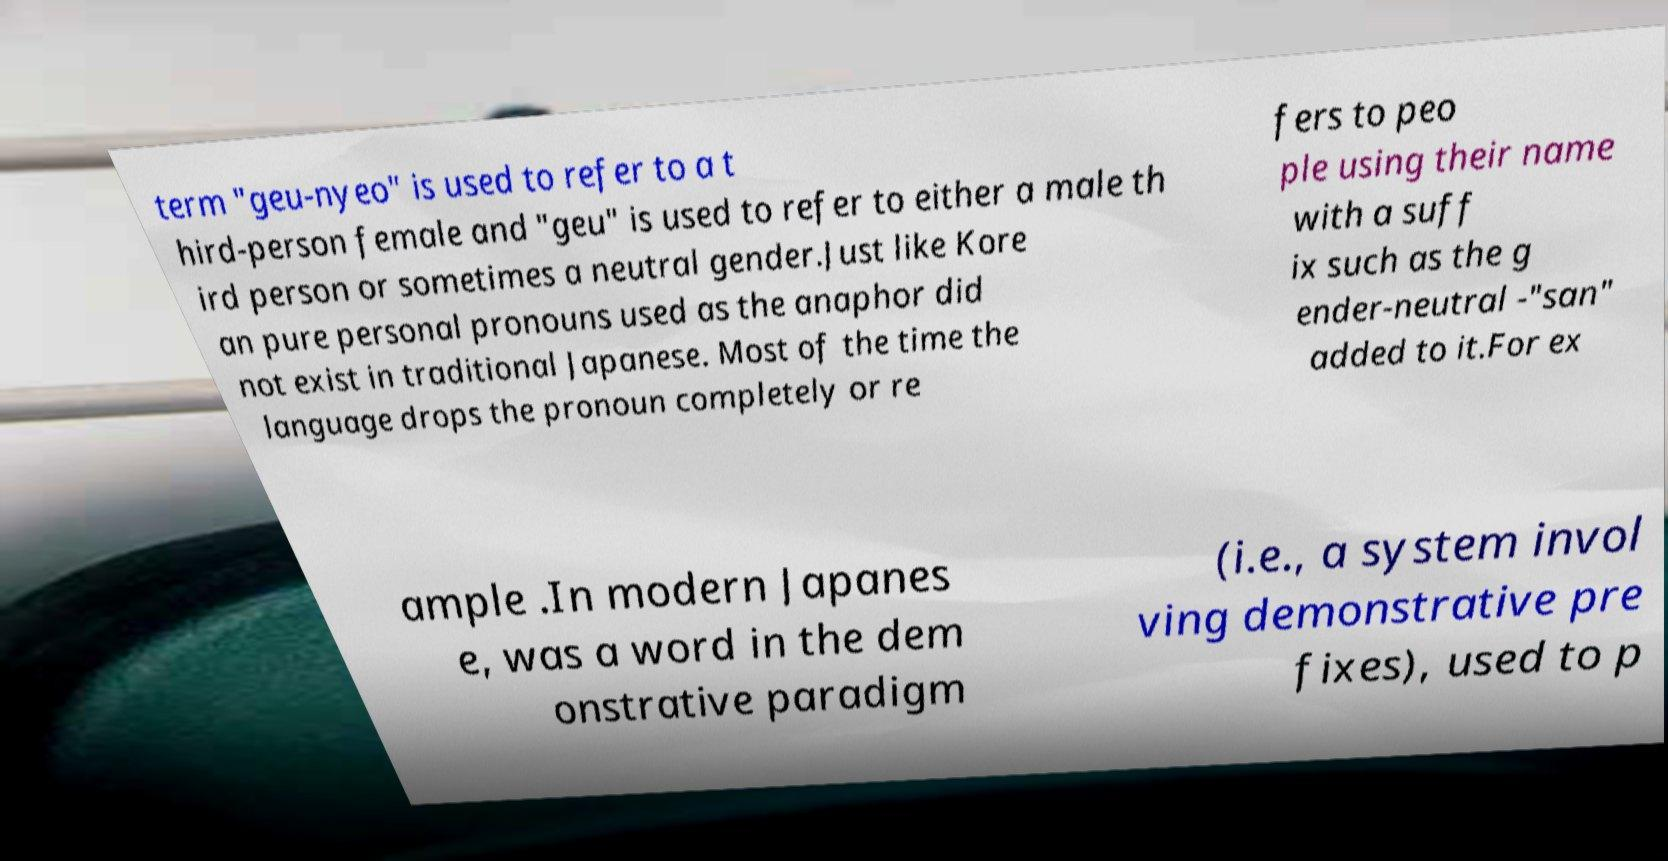Please read and relay the text visible in this image. What does it say? term "geu-nyeo" is used to refer to a t hird-person female and "geu" is used to refer to either a male th ird person or sometimes a neutral gender.Just like Kore an pure personal pronouns used as the anaphor did not exist in traditional Japanese. Most of the time the language drops the pronoun completely or re fers to peo ple using their name with a suff ix such as the g ender-neutral -"san" added to it.For ex ample .In modern Japanes e, was a word in the dem onstrative paradigm (i.e., a system invol ving demonstrative pre fixes), used to p 